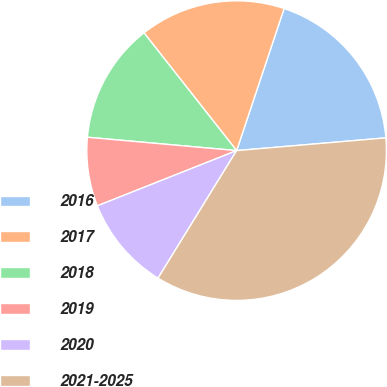Convert chart. <chart><loc_0><loc_0><loc_500><loc_500><pie_chart><fcel>2016<fcel>2017<fcel>2018<fcel>2019<fcel>2020<fcel>2021-2025<nl><fcel>18.51%<fcel>15.74%<fcel>12.97%<fcel>7.43%<fcel>10.2%<fcel>35.14%<nl></chart> 